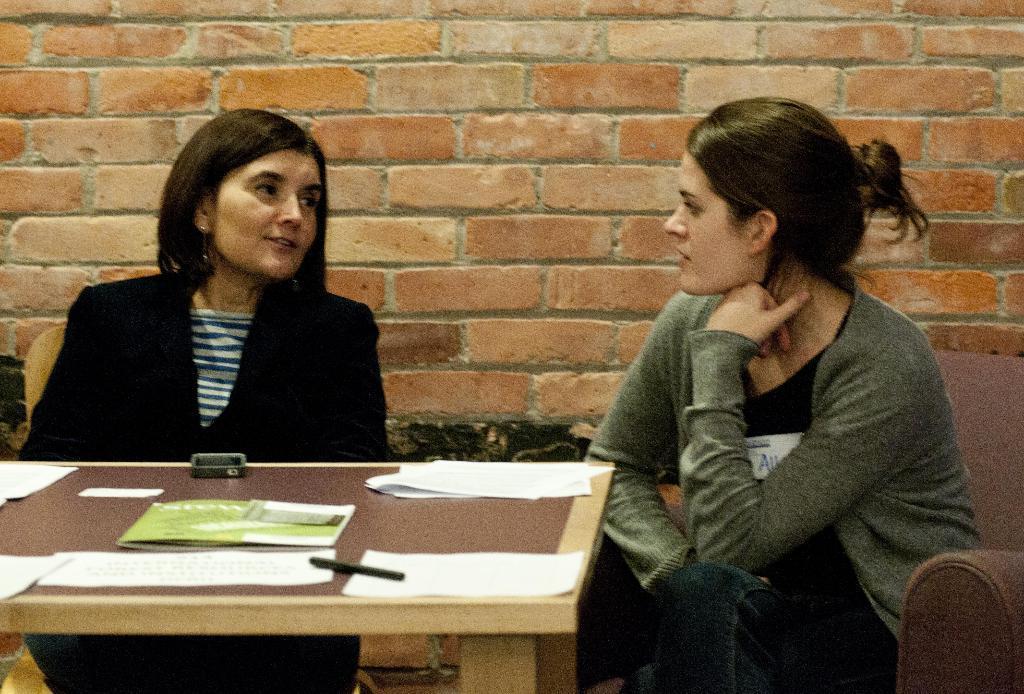How would you summarize this image in a sentence or two? In this image on left a lady wearing sweater sitting beside a lady wearing black coat. In front of her on a table there are papers,pen. In the background there is wall. 